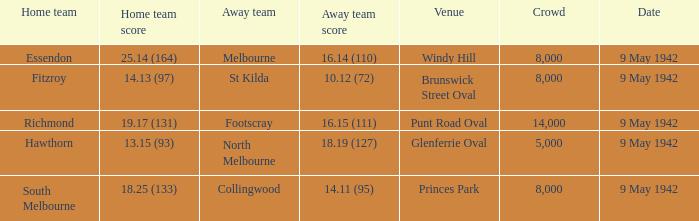How many people attended the game where Footscray was away? 14000.0. 